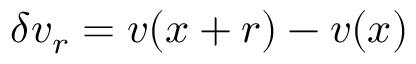<formula> <loc_0><loc_0><loc_500><loc_500>\delta v _ { r } = v ( x + r ) - v ( x )</formula> 